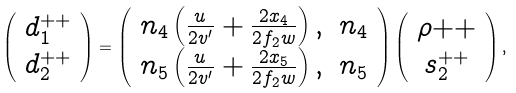Convert formula to latex. <formula><loc_0><loc_0><loc_500><loc_500>\left ( \begin{array} { c } d _ { 1 } ^ { + + } \\ d _ { 2 } ^ { + + } \\ \end{array} \right ) = \left ( \begin{array} { c c } n _ { 4 } \left ( \frac { u } { 2 v ^ { \prime } } + \frac { 2 x _ { 4 } } { 2 f _ { 2 } w } \right ) , & n _ { 4 } \\ n _ { 5 } \left ( \frac { u } { 2 v ^ { \prime } } + \frac { 2 x _ { 5 } } { 2 f _ { 2 } w } \right ) , & n _ { 5 } \end{array} \right ) \left ( \begin{array} { c } \rho { + + } \\ s _ { 2 } ^ { + + } \end{array} \right ) ,</formula> 